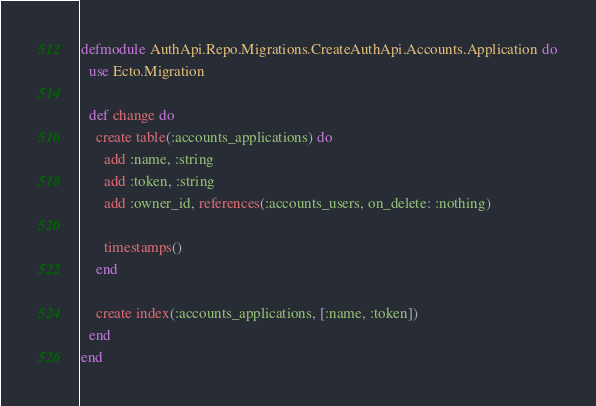<code> <loc_0><loc_0><loc_500><loc_500><_Elixir_>defmodule AuthApi.Repo.Migrations.CreateAuthApi.Accounts.Application do
  use Ecto.Migration

  def change do
    create table(:accounts_applications) do
      add :name, :string
      add :token, :string
      add :owner_id, references(:accounts_users, on_delete: :nothing)

      timestamps()
    end

    create index(:accounts_applications, [:name, :token])
  end
end
</code> 